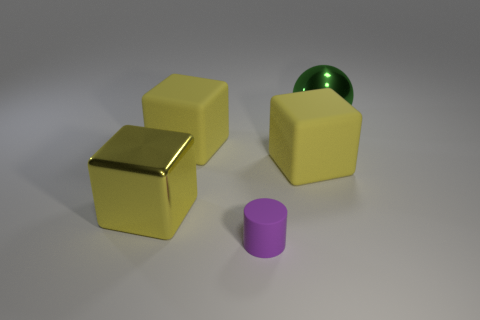Add 5 big yellow objects. How many objects exist? 10 Subtract all cylinders. How many objects are left? 4 Subtract 0 blue blocks. How many objects are left? 5 Subtract all red metal cylinders. Subtract all big yellow rubber blocks. How many objects are left? 3 Add 3 balls. How many balls are left? 4 Add 5 yellow things. How many yellow things exist? 8 